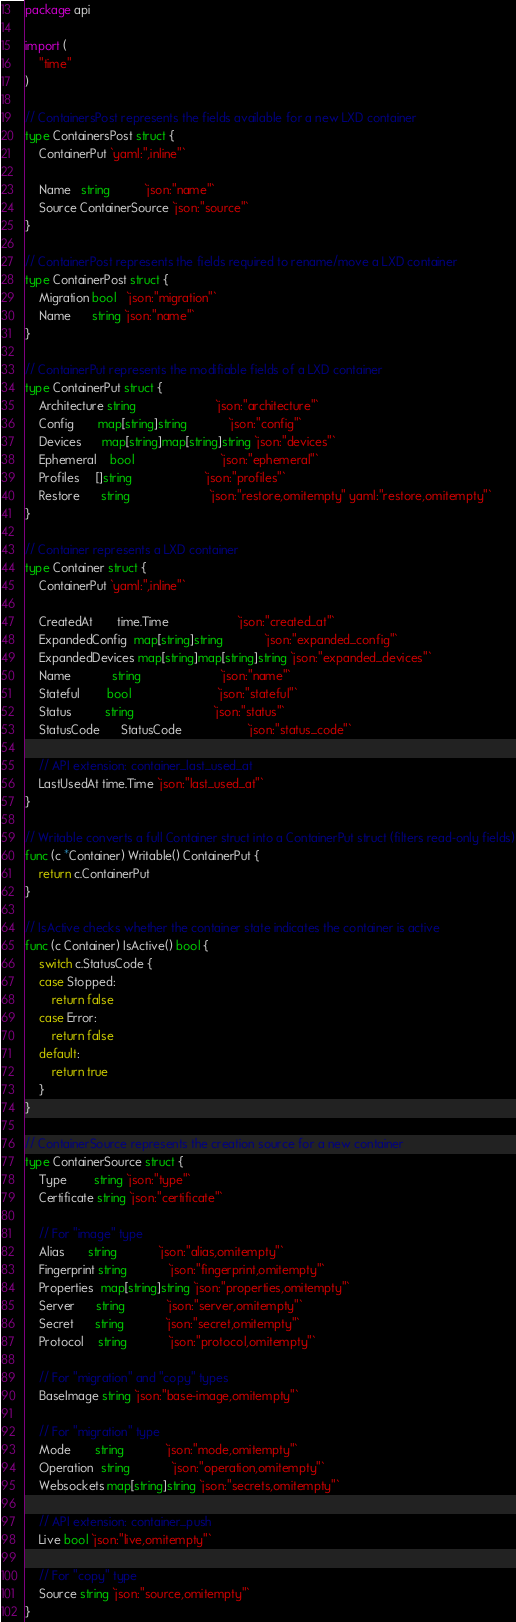Convert code to text. <code><loc_0><loc_0><loc_500><loc_500><_Go_>package api

import (
	"time"
)

// ContainersPost represents the fields available for a new LXD container
type ContainersPost struct {
	ContainerPut `yaml:",inline"`

	Name   string          `json:"name"`
	Source ContainerSource `json:"source"`
}

// ContainerPost represents the fields required to rename/move a LXD container
type ContainerPost struct {
	Migration bool   `json:"migration"`
	Name      string `json:"name"`
}

// ContainerPut represents the modifiable fields of a LXD container
type ContainerPut struct {
	Architecture string                       `json:"architecture"`
	Config       map[string]string            `json:"config"`
	Devices      map[string]map[string]string `json:"devices"`
	Ephemeral    bool                         `json:"ephemeral"`
	Profiles     []string                     `json:"profiles"`
	Restore      string                       `json:"restore,omitempty" yaml:"restore,omitempty"`
}

// Container represents a LXD container
type Container struct {
	ContainerPut `yaml:",inline"`

	CreatedAt       time.Time                    `json:"created_at"`
	ExpandedConfig  map[string]string            `json:"expanded_config"`
	ExpandedDevices map[string]map[string]string `json:"expanded_devices"`
	Name            string                       `json:"name"`
	Stateful        bool                         `json:"stateful"`
	Status          string                       `json:"status"`
	StatusCode      StatusCode                   `json:"status_code"`

	// API extension: container_last_used_at
	LastUsedAt time.Time `json:"last_used_at"`
}

// Writable converts a full Container struct into a ContainerPut struct (filters read-only fields)
func (c *Container) Writable() ContainerPut {
	return c.ContainerPut
}

// IsActive checks whether the container state indicates the container is active
func (c Container) IsActive() bool {
	switch c.StatusCode {
	case Stopped:
		return false
	case Error:
		return false
	default:
		return true
	}
}

// ContainerSource represents the creation source for a new container
type ContainerSource struct {
	Type        string `json:"type"`
	Certificate string `json:"certificate"`

	// For "image" type
	Alias       string            `json:"alias,omitempty"`
	Fingerprint string            `json:"fingerprint,omitempty"`
	Properties  map[string]string `json:"properties,omitempty"`
	Server      string            `json:"server,omitempty"`
	Secret      string            `json:"secret,omitempty"`
	Protocol    string            `json:"protocol,omitempty"`

	// For "migration" and "copy" types
	BaseImage string `json:"base-image,omitempty"`

	// For "migration" type
	Mode       string            `json:"mode,omitempty"`
	Operation  string            `json:"operation,omitempty"`
	Websockets map[string]string `json:"secrets,omitempty"`

	// API extension: container_push
	Live bool `json:"live,omitempty"`

	// For "copy" type
	Source string `json:"source,omitempty"`
}
</code> 